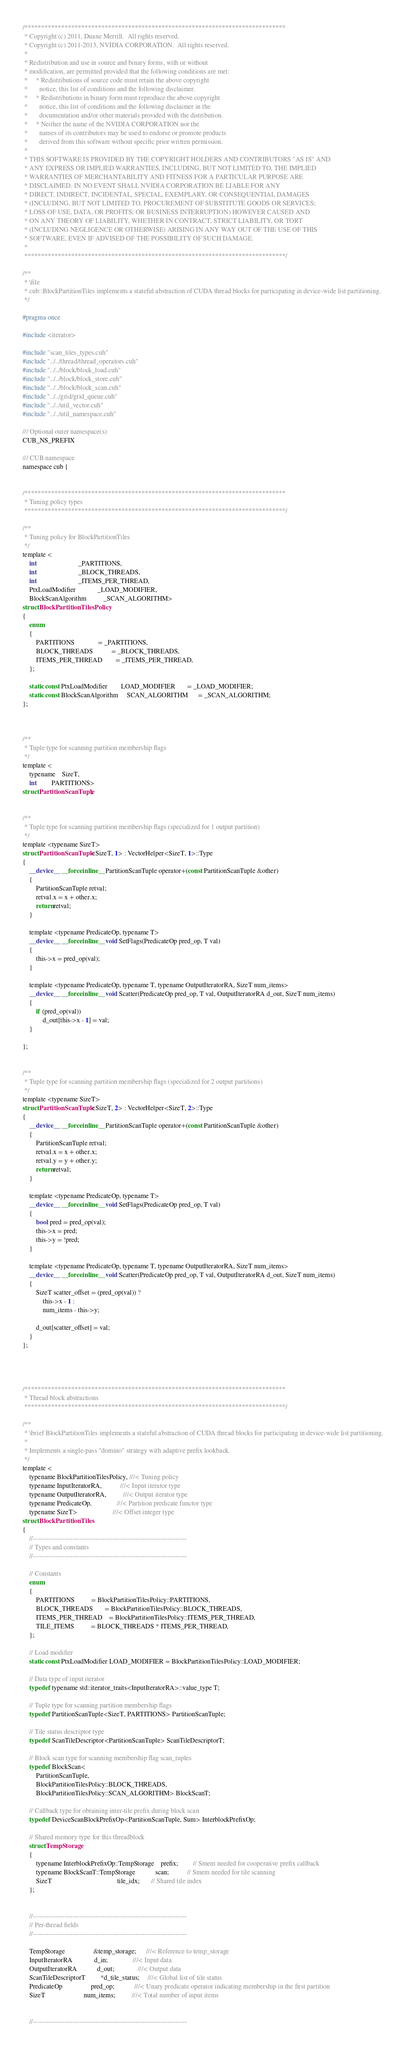Convert code to text. <code><loc_0><loc_0><loc_500><loc_500><_Cuda_>/******************************************************************************
 * Copyright (c) 2011, Duane Merrill.  All rights reserved.
 * Copyright (c) 2011-2013, NVIDIA CORPORATION.  All rights reserved.
 *
 * Redistribution and use in source and binary forms, with or without
 * modification, are permitted provided that the following conditions are met:
 *     * Redistributions of source code must retain the above copyright
 *       notice, this list of conditions and the following disclaimer.
 *     * Redistributions in binary form must reproduce the above copyright
 *       notice, this list of conditions and the following disclaimer in the
 *       documentation and/or other materials provided with the distribution.
 *     * Neither the name of the NVIDIA CORPORATION nor the
 *       names of its contributors may be used to endorse or promote products
 *       derived from this software without specific prior written permission.
 *
 * THIS SOFTWARE IS PROVIDED BY THE COPYRIGHT HOLDERS AND CONTRIBUTORS "AS IS" AND
 * ANY EXPRESS OR IMPLIED WARRANTIES, INCLUDING, BUT NOT LIMITED TO, THE IMPLIED
 * WARRANTIES OF MERCHANTABILITY AND FITNESS FOR A PARTICULAR PURPOSE ARE
 * DISCLAIMED. IN NO EVENT SHALL NVIDIA CORPORATION BE LIABLE FOR ANY
 * DIRECT, INDIRECT, INCIDENTAL, SPECIAL, EXEMPLARY, OR CONSEQUENTIAL DAMAGES
 * (INCLUDING, BUT NOT LIMITED TO, PROCUREMENT OF SUBSTITUTE GOODS OR SERVICES;
 * LOSS OF USE, DATA, OR PROFITS; OR BUSINESS INTERRUPTION) HOWEVER CAUSED AND
 * ON ANY THEORY OF LIABILITY, WHETHER IN CONTRACT, STRICT LIABILITY, OR TORT
 * (INCLUDING NEGLIGENCE OR OTHERWISE) ARISING IN ANY WAY OUT OF THE USE OF THIS
 * SOFTWARE, EVEN IF ADVISED OF THE POSSIBILITY OF SUCH DAMAGE.
 *
 ******************************************************************************/

/**
 * \file
 * cub::BlockPartitionTiles implements a stateful abstraction of CUDA thread blocks for participating in device-wide list partitioning.
 */

#pragma once

#include <iterator>

#include "scan_tiles_types.cuh"
#include "../../thread/thread_operators.cuh"
#include "../../block/block_load.cuh"
#include "../../block/block_store.cuh"
#include "../../block/block_scan.cuh"
#include "../../grid/grid_queue.cuh"
#include "../../util_vector.cuh"
#include "../../util_namespace.cuh"

/// Optional outer namespace(s)
CUB_NS_PREFIX

/// CUB namespace
namespace cub {


/******************************************************************************
 * Tuning policy types
 ******************************************************************************/

/**
 * Tuning policy for BlockPartitionTiles
 */
template <
    int                         _PARTITIONS,
    int                         _BLOCK_THREADS,
    int                         _ITEMS_PER_THREAD,
    PtxLoadModifier             _LOAD_MODIFIER,
    BlockScanAlgorithm          _SCAN_ALGORITHM>
struct BlockPartitionTilesPolicy
{
    enum
    {
        PARTITIONS              = _PARTITIONS,
        BLOCK_THREADS           = _BLOCK_THREADS,
        ITEMS_PER_THREAD        = _ITEMS_PER_THREAD,
    };

    static const PtxLoadModifier        LOAD_MODIFIER       = _LOAD_MODIFIER;
    static const BlockScanAlgorithm     SCAN_ALGORITHM      = _SCAN_ALGORITHM;
};



/**
 * Tuple type for scanning partition membership flags
 */
template <
    typename    SizeT,
    int         PARTITIONS>
struct PartitionScanTuple;


/**
 * Tuple type for scanning partition membership flags (specialized for 1 output partition)
 */
template <typename SizeT>
struct PartitionScanTuple<SizeT, 1> : VectorHelper<SizeT, 1>::Type
{
    __device__ __forceinline__ PartitionScanTuple operator+(const PartitionScanTuple &other)
    {
        PartitionScanTuple retval;
        retval.x = x + other.x;
        return retval;
    }

    template <typename PredicateOp, typename T>
    __device__ __forceinline__ void SetFlags(PredicateOp pred_op, T val)
    {
        this->x = pred_op(val);
    }

    template <typename PredicateOp, typename T, typename OutputIteratorRA, SizeT num_items>
    __device__ __forceinline__ void Scatter(PredicateOp pred_op, T val, OutputIteratorRA d_out, SizeT num_items)
    {
        if (pred_op(val))
            d_out[this->x - 1] = val;
    }

};


/**
 * Tuple type for scanning partition membership flags (specialized for 2 output partitions)
 */
template <typename SizeT>
struct PartitionScanTuple<SizeT, 2> : VectorHelper<SizeT, 2>::Type
{
    __device__ __forceinline__ PartitionScanTuple operator+(const PartitionScanTuple &other)
    {
        PartitionScanTuple retval;
        retval.x = x + other.x;
        retval.y = y + other.y;
        return retval;
    }

    template <typename PredicateOp, typename T>
    __device__ __forceinline__ void SetFlags(PredicateOp pred_op, T val)
    {
        bool pred = pred_op(val);
        this->x = pred;
        this->y = !pred;
    }

    template <typename PredicateOp, typename T, typename OutputIteratorRA, SizeT num_items>
    __device__ __forceinline__ void Scatter(PredicateOp pred_op, T val, OutputIteratorRA d_out, SizeT num_items)
    {
        SizeT scatter_offset = (pred_op(val)) ?
            this->x - 1 :
            num_items - this->y;

        d_out[scatter_offset] = val;
    }
};




/******************************************************************************
 * Thread block abstractions
 ******************************************************************************/

/**
 * \brief BlockPartitionTiles implements a stateful abstraction of CUDA thread blocks for participating in device-wide list partitioning.
 *
 * Implements a single-pass "domino" strategy with adaptive prefix lookback.
 */
template <
    typename BlockPartitionTilesPolicy, ///< Tuning policy
    typename InputIteratorRA,           ///< Input iterator type
    typename OutputIteratorRA,          ///< Output iterator type
    typename PredicateOp,               ///< Partition predicate functor type
    typename SizeT>                     ///< Offset integer type
struct BlockPartitionTiles
{
    //---------------------------------------------------------------------
    // Types and constants
    //---------------------------------------------------------------------

    // Constants
    enum
    {
        PARTITIONS          = BlockPartitionTilesPolicy::PARTITIONS,
        BLOCK_THREADS       = BlockPartitionTilesPolicy::BLOCK_THREADS,
        ITEMS_PER_THREAD    = BlockPartitionTilesPolicy::ITEMS_PER_THREAD,
        TILE_ITEMS          = BLOCK_THREADS * ITEMS_PER_THREAD,
    };

    // Load modifier
    static const PtxLoadModifier LOAD_MODIFIER = BlockPartitionTilesPolicy::LOAD_MODIFIER;

    // Data type of input iterator
    typedef typename std::iterator_traits<InputIteratorRA>::value_type T;

    // Tuple type for scanning partition membership flags
    typedef PartitionScanTuple<SizeT, PARTITIONS> PartitionScanTuple;

    // Tile status descriptor type
    typedef ScanTileDescriptor<PartitionScanTuple> ScanTileDescriptorT;

    // Block scan type for scanning membership flag scan_tuples
    typedef BlockScan<
        PartitionScanTuple,
        BlockPartitionTilesPolicy::BLOCK_THREADS,
        BlockPartitionTilesPolicy::SCAN_ALGORITHM> BlockScanT;

    // Callback type for obtaining inter-tile prefix during block scan
    typedef DeviceScanBlockPrefixOp<PartitionScanTuple, Sum> InterblockPrefixOp;

    // Shared memory type for this threadblock
    struct TempStorage
    {
        typename InterblockPrefixOp::TempStorage    prefix;         // Smem needed for cooperative prefix callback
        typename BlockScanT::TempStorage            scan;           // Smem needed for tile scanning
        SizeT                                       tile_idx;       // Shared tile index
    };


    //---------------------------------------------------------------------
    // Per-thread fields
    //---------------------------------------------------------------------

    TempStorage                 &temp_storage;      ///< Reference to temp_storage
    InputIteratorRA             d_in;               ///< Input data
    OutputIteratorRA            d_out;              ///< Output data
    ScanTileDescriptorT         *d_tile_status;     ///< Global list of tile status
    PredicateOp                 pred_op;            ///< Unary predicate operator indicating membership in the first partition
    SizeT                       num_items;          ///< Total number of input items


    //---------------------------------------------------------------------</code> 